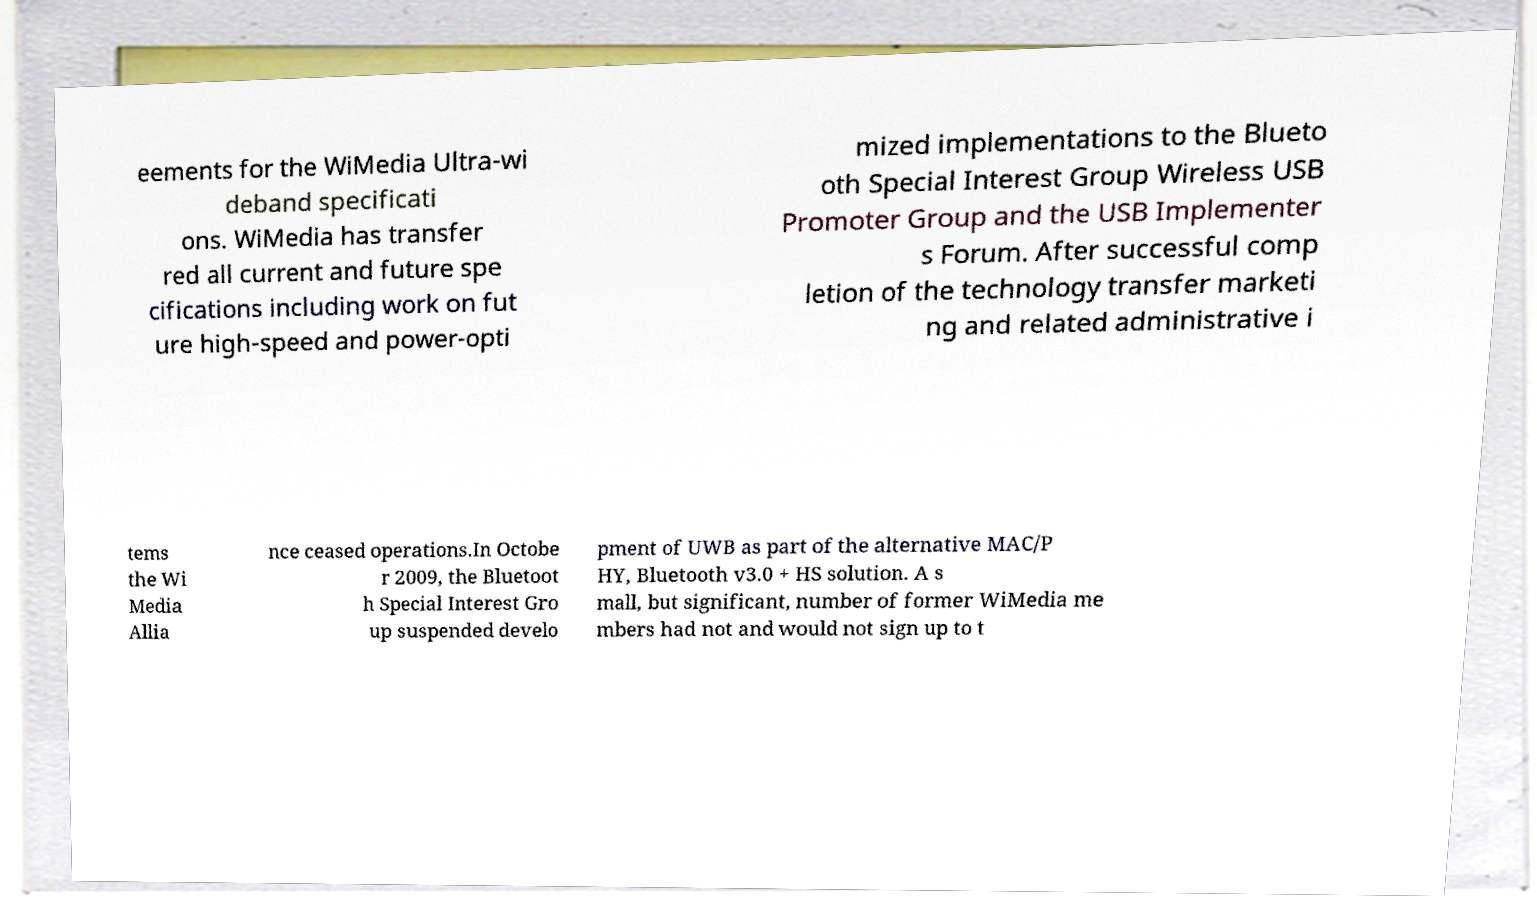Can you accurately transcribe the text from the provided image for me? eements for the WiMedia Ultra-wi deband specificati ons. WiMedia has transfer red all current and future spe cifications including work on fut ure high-speed and power-opti mized implementations to the Blueto oth Special Interest Group Wireless USB Promoter Group and the USB Implementer s Forum. After successful comp letion of the technology transfer marketi ng and related administrative i tems the Wi Media Allia nce ceased operations.In Octobe r 2009, the Bluetoot h Special Interest Gro up suspended develo pment of UWB as part of the alternative MAC/P HY, Bluetooth v3.0 + HS solution. A s mall, but significant, number of former WiMedia me mbers had not and would not sign up to t 